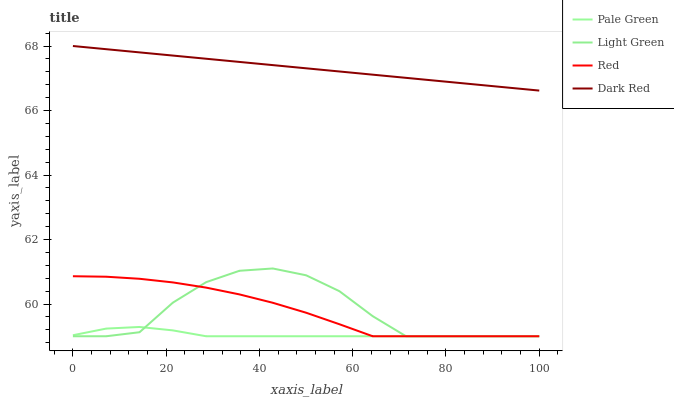Does Pale Green have the minimum area under the curve?
Answer yes or no. Yes. Does Dark Red have the maximum area under the curve?
Answer yes or no. Yes. Does Red have the minimum area under the curve?
Answer yes or no. No. Does Red have the maximum area under the curve?
Answer yes or no. No. Is Dark Red the smoothest?
Answer yes or no. Yes. Is Light Green the roughest?
Answer yes or no. Yes. Is Pale Green the smoothest?
Answer yes or no. No. Is Pale Green the roughest?
Answer yes or no. No. Does Pale Green have the lowest value?
Answer yes or no. Yes. Does Dark Red have the highest value?
Answer yes or no. Yes. Does Red have the highest value?
Answer yes or no. No. Is Red less than Dark Red?
Answer yes or no. Yes. Is Dark Red greater than Red?
Answer yes or no. Yes. Does Light Green intersect Red?
Answer yes or no. Yes. Is Light Green less than Red?
Answer yes or no. No. Is Light Green greater than Red?
Answer yes or no. No. Does Red intersect Dark Red?
Answer yes or no. No. 